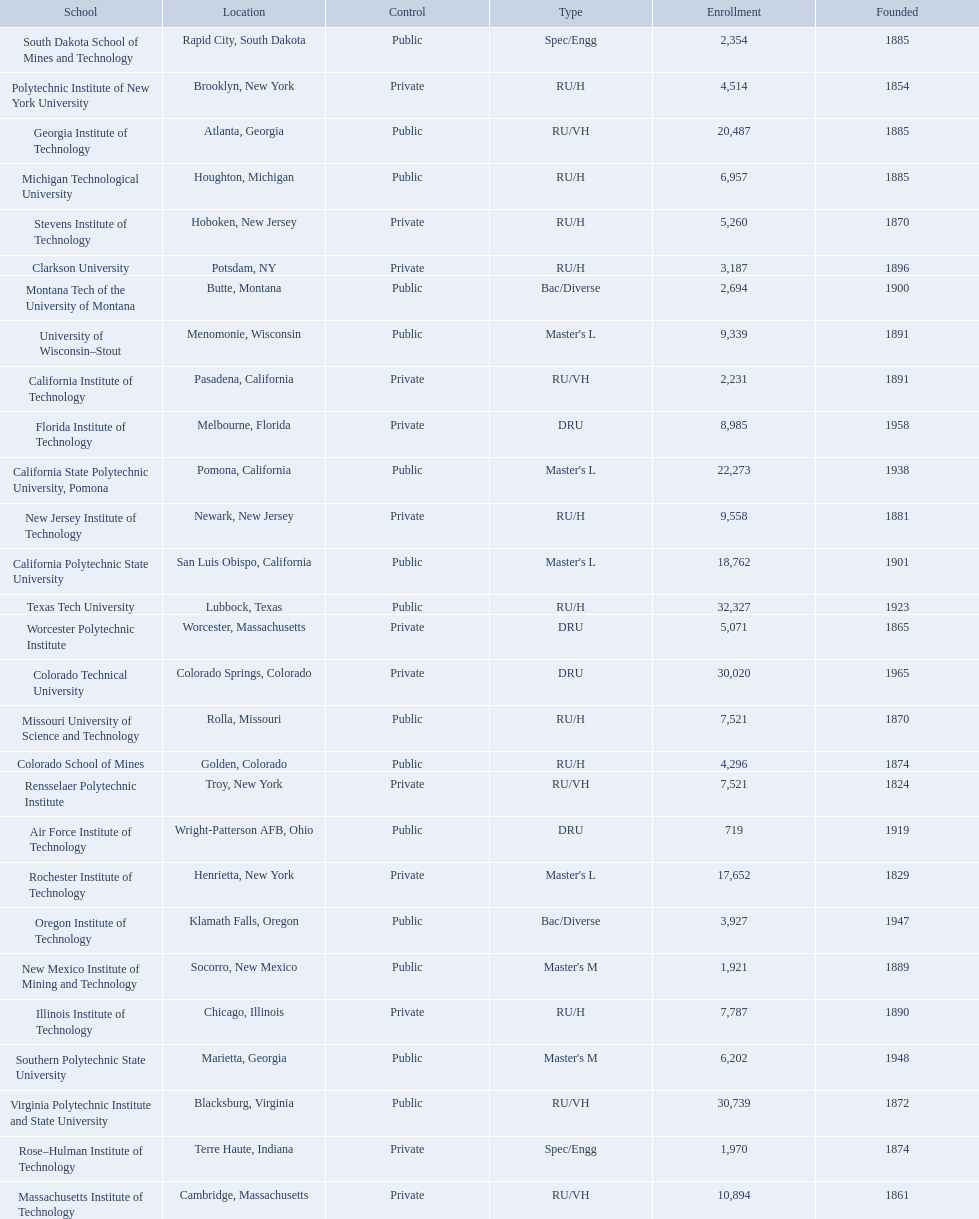What are the listed enrollment numbers of us universities? 719, 2,231, 18,762, 22,273, 3,187, 4,296, 30,020, 8,985, 20,487, 7,787, 10,894, 6,957, 7,521, 2,694, 9,558, 1,921, 3,927, 4,514, 7,521, 17,652, 1,970, 2,354, 6,202, 5,260, 32,327, 9,339, 30,739, 5,071. Of these, which has the highest value? 32,327. What are the listed names of us universities? Air Force Institute of Technology, California Institute of Technology, California Polytechnic State University, California State Polytechnic University, Pomona, Clarkson University, Colorado School of Mines, Colorado Technical University, Florida Institute of Technology, Georgia Institute of Technology, Illinois Institute of Technology, Massachusetts Institute of Technology, Michigan Technological University, Missouri University of Science and Technology, Montana Tech of the University of Montana, New Jersey Institute of Technology, New Mexico Institute of Mining and Technology, Oregon Institute of Technology, Polytechnic Institute of New York University, Rensselaer Polytechnic Institute, Rochester Institute of Technology, Rose–Hulman Institute of Technology, South Dakota School of Mines and Technology, Southern Polytechnic State University, Stevens Institute of Technology, Texas Tech University, University of Wisconsin–Stout, Virginia Polytechnic Institute and State University, Worcester Polytechnic Institute. Which of these correspond to the previously listed highest enrollment value? Texas Tech University. 